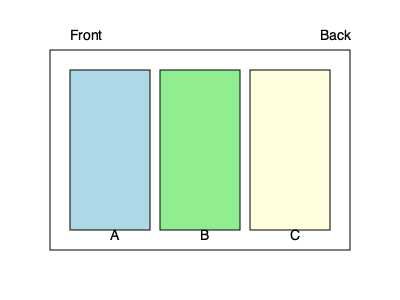In a data center, you need to optimize the placement of three server racks (A, B, and C) in a row to minimize cooling costs. The cooling system blows cold air from front to back. If rack A generates 8kW of heat, rack B generates 6kW, and rack C generates 10kW, what is the optimal arrangement of the racks from front to back to minimize the overall cooling load? To optimize the placement of server racks and minimize cooling costs, we need to arrange them in order of increasing heat generation from front to back. This approach ensures that cooler air reaches the less heat-generating racks first, and the hottest rack is placed at the back where it can dissipate heat without affecting the other racks.

Step 1: Identify the heat generation of each rack:
- Rack A: 8kW
- Rack B: 6kW
- Rack C: 10kW

Step 2: Order the racks from lowest to highest heat generation:
1. Rack B (6kW)
2. Rack A (8kW)
3. Rack C (10kW)

Step 3: Arrange the racks from front to back based on this order:
Front: Rack B (6kW) → Rack A (8kW) → Rack C (10kW) : Back

This arrangement ensures that:
1. The coolest air hits the rack with the lowest heat output first.
2. The middle rack receives slightly warmer air but still generates less heat than the back rack.
3. The hottest rack is placed at the back, where its heat output won't affect the cooling of the other racks.

By following this arrangement, we minimize the overall cooling load and optimize the efficiency of the cooling system.
Answer: B → A → C 